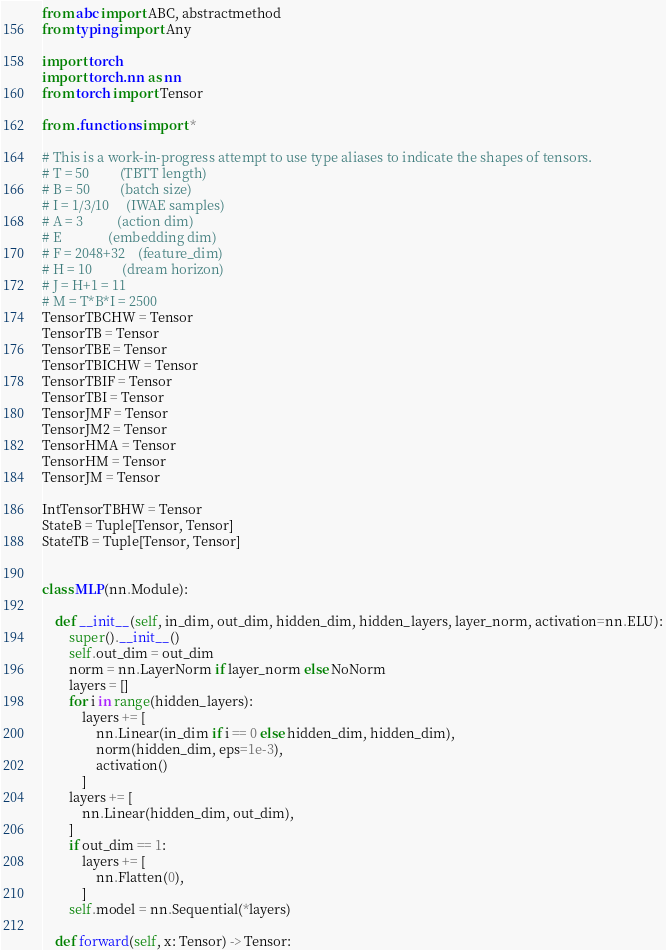<code> <loc_0><loc_0><loc_500><loc_500><_Python_>from abc import ABC, abstractmethod
from typing import Any

import torch
import torch.nn as nn
from torch import Tensor

from .functions import *

# This is a work-in-progress attempt to use type aliases to indicate the shapes of tensors.
# T = 50         (TBTT length)
# B = 50         (batch size)
# I = 1/3/10     (IWAE samples)
# A = 3          (action dim)
# E              (embedding dim)
# F = 2048+32    (feature_dim)
# H = 10         (dream horizon)
# J = H+1 = 11
# M = T*B*I = 2500
TensorTBCHW = Tensor
TensorTB = Tensor
TensorTBE = Tensor
TensorTBICHW = Tensor
TensorTBIF = Tensor
TensorTBI = Tensor
TensorJMF = Tensor
TensorJM2 = Tensor
TensorHMA = Tensor
TensorHM = Tensor
TensorJM = Tensor

IntTensorTBHW = Tensor
StateB = Tuple[Tensor, Tensor]
StateTB = Tuple[Tensor, Tensor]


class MLP(nn.Module):

    def __init__(self, in_dim, out_dim, hidden_dim, hidden_layers, layer_norm, activation=nn.ELU):
        super().__init__()
        self.out_dim = out_dim
        norm = nn.LayerNorm if layer_norm else NoNorm
        layers = []
        for i in range(hidden_layers):
            layers += [
                nn.Linear(in_dim if i == 0 else hidden_dim, hidden_dim),
                norm(hidden_dim, eps=1e-3),
                activation()
            ]
        layers += [
            nn.Linear(hidden_dim, out_dim),
        ]
        if out_dim == 1:
            layers += [
                nn.Flatten(0),
            ]
        self.model = nn.Sequential(*layers)

    def forward(self, x: Tensor) -> Tensor:</code> 